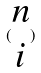Convert formula to latex. <formula><loc_0><loc_0><loc_500><loc_500>( \begin{matrix} n \\ i \end{matrix} )</formula> 